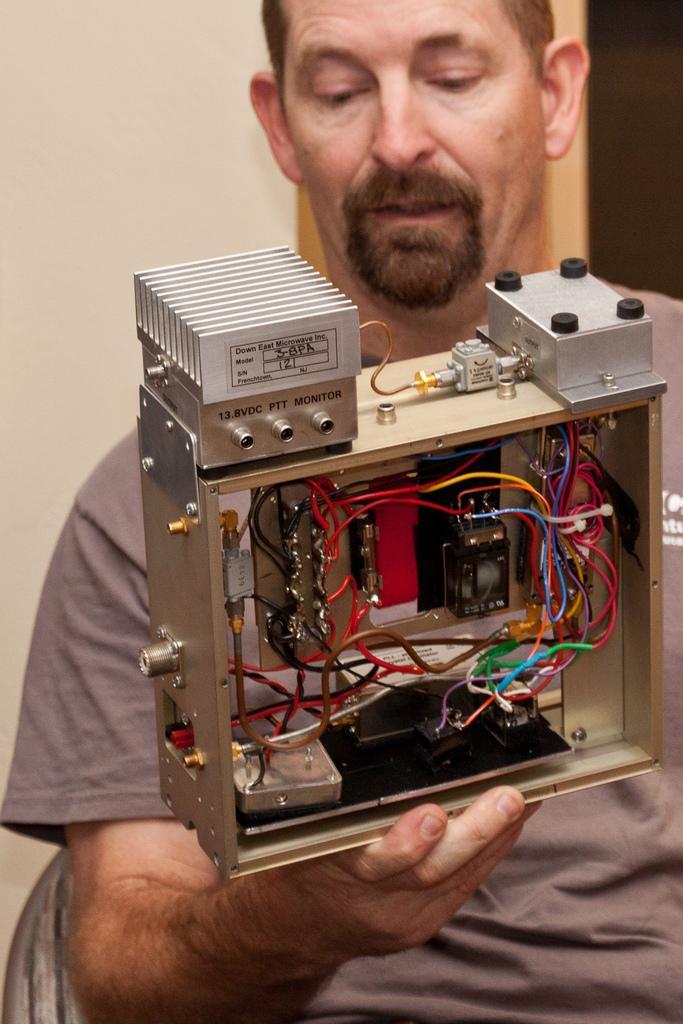Could you give a brief overview of what you see in this image? In this image, in the middle, we can see a man sitting on the chair and holding an electrical equipment. In the background, we can see a wall and black color. 